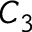<formula> <loc_0><loc_0><loc_500><loc_500>C _ { 3 }</formula> 